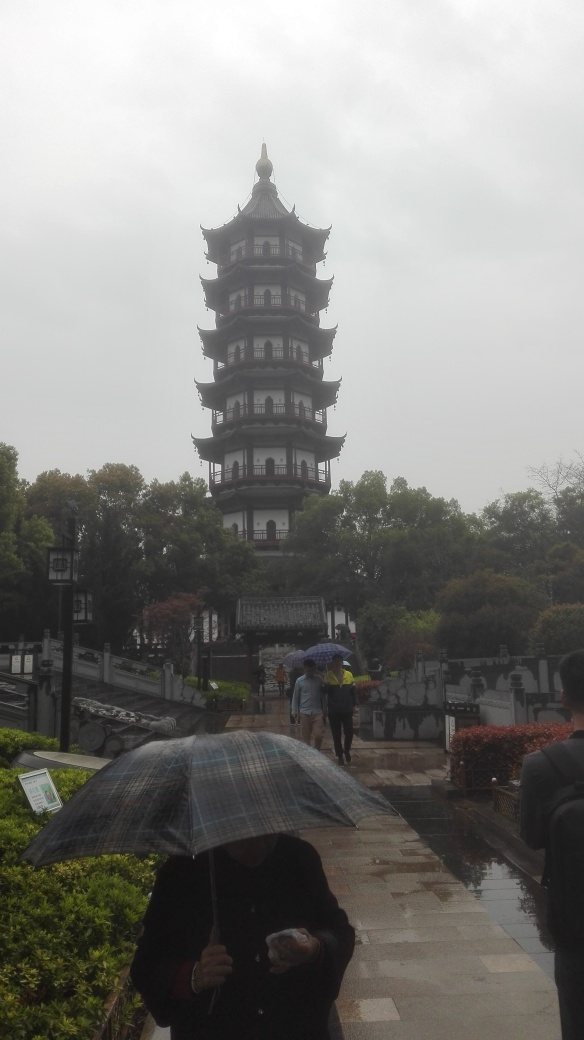What is the composition of the image?
A. Acceptable
B. Excellent
C. Unappealing
D. Poor The composition of the image can be considered 'B. Excellent' due to the clear foreground focus on the majestic, multi-tiered tower set against a diffused backdrop. The overcast sky provides a soft light that accentuates the architectural details without harsh shadows. Moreover, the inclusion of people carrying umbrellas suggests a story about daily life and the weather condition, adding to the image's depth and interest. 